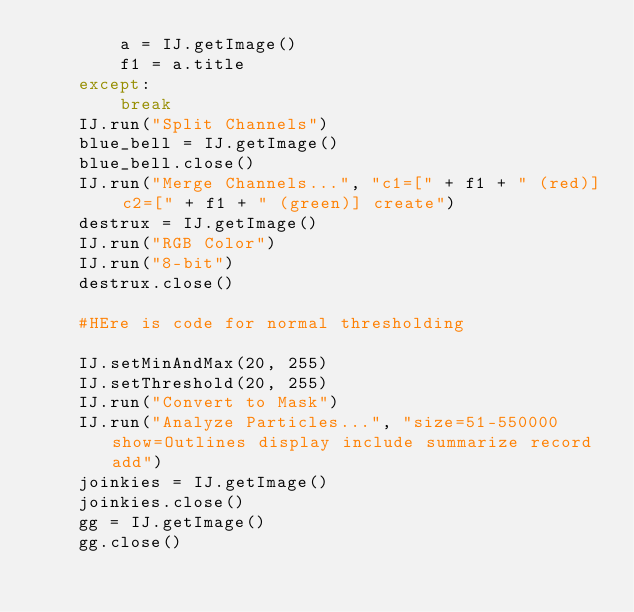Convert code to text. <code><loc_0><loc_0><loc_500><loc_500><_Python_>        a = IJ.getImage()
        f1 = a.title
    except:
        break
    IJ.run("Split Channels")
    blue_bell = IJ.getImage()
    blue_bell.close()
    IJ.run("Merge Channels...", "c1=[" + f1 + " (red)] c2=[" + f1 + " (green)] create")
    destrux = IJ.getImage()
    IJ.run("RGB Color")
    IJ.run("8-bit")
    destrux.close()

    #HEre is code for normal thresholding

    IJ.setMinAndMax(20, 255)
    IJ.setThreshold(20, 255)
    IJ.run("Convert to Mask")
    IJ.run("Analyze Particles...", "size=51-550000 show=Outlines display include summarize record add")
    joinkies = IJ.getImage()
    joinkies.close()
    gg = IJ.getImage()
    gg.close()
</code> 